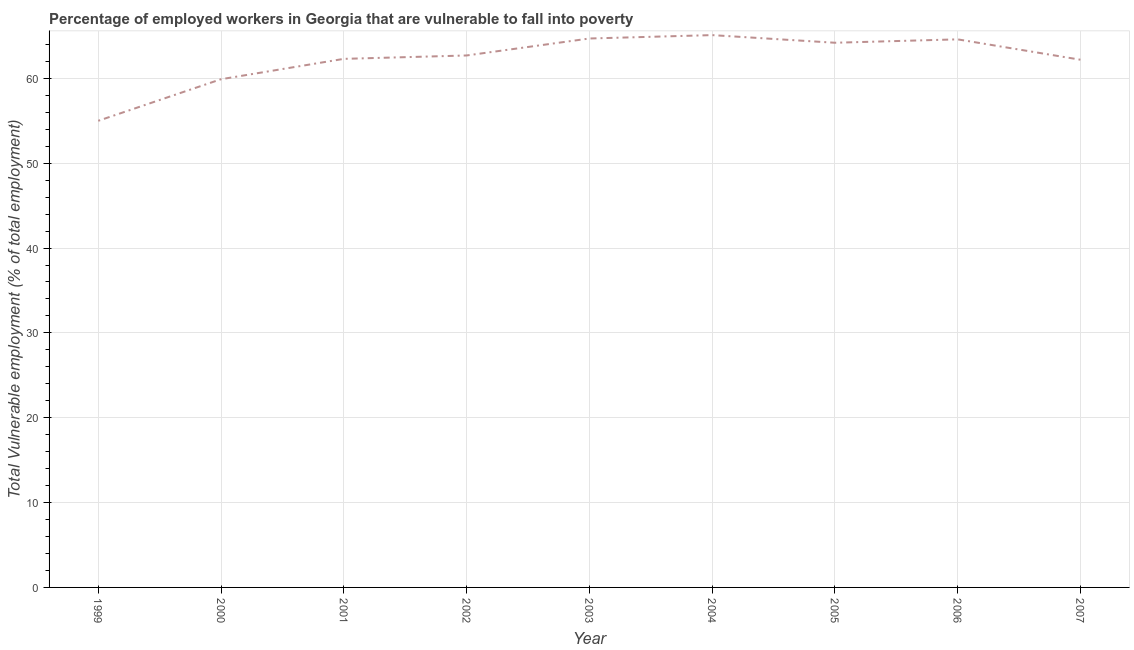What is the total vulnerable employment in 2005?
Make the answer very short. 64.2. Across all years, what is the maximum total vulnerable employment?
Your answer should be very brief. 65.1. Across all years, what is the minimum total vulnerable employment?
Offer a very short reply. 55. In which year was the total vulnerable employment maximum?
Your response must be concise. 2004. In which year was the total vulnerable employment minimum?
Make the answer very short. 1999. What is the sum of the total vulnerable employment?
Make the answer very short. 560.7. What is the difference between the total vulnerable employment in 2005 and 2007?
Give a very brief answer. 2. What is the average total vulnerable employment per year?
Give a very brief answer. 62.3. What is the median total vulnerable employment?
Provide a succinct answer. 62.7. In how many years, is the total vulnerable employment greater than 50 %?
Offer a very short reply. 9. Do a majority of the years between 2000 and 2002 (inclusive) have total vulnerable employment greater than 48 %?
Offer a very short reply. Yes. What is the ratio of the total vulnerable employment in 2004 to that in 2005?
Your answer should be very brief. 1.01. Is the difference between the total vulnerable employment in 2001 and 2007 greater than the difference between any two years?
Provide a short and direct response. No. What is the difference between the highest and the second highest total vulnerable employment?
Provide a succinct answer. 0.4. What is the difference between the highest and the lowest total vulnerable employment?
Ensure brevity in your answer.  10.1. In how many years, is the total vulnerable employment greater than the average total vulnerable employment taken over all years?
Your answer should be compact. 5. Does the total vulnerable employment monotonically increase over the years?
Your response must be concise. No. How many lines are there?
Provide a short and direct response. 1. Does the graph contain any zero values?
Your answer should be very brief. No. Does the graph contain grids?
Ensure brevity in your answer.  Yes. What is the title of the graph?
Make the answer very short. Percentage of employed workers in Georgia that are vulnerable to fall into poverty. What is the label or title of the X-axis?
Keep it short and to the point. Year. What is the label or title of the Y-axis?
Provide a succinct answer. Total Vulnerable employment (% of total employment). What is the Total Vulnerable employment (% of total employment) of 1999?
Your response must be concise. 55. What is the Total Vulnerable employment (% of total employment) in 2000?
Your answer should be very brief. 59.9. What is the Total Vulnerable employment (% of total employment) in 2001?
Your answer should be very brief. 62.3. What is the Total Vulnerable employment (% of total employment) in 2002?
Your answer should be very brief. 62.7. What is the Total Vulnerable employment (% of total employment) of 2003?
Give a very brief answer. 64.7. What is the Total Vulnerable employment (% of total employment) of 2004?
Your answer should be compact. 65.1. What is the Total Vulnerable employment (% of total employment) in 2005?
Your answer should be very brief. 64.2. What is the Total Vulnerable employment (% of total employment) of 2006?
Make the answer very short. 64.6. What is the Total Vulnerable employment (% of total employment) in 2007?
Your response must be concise. 62.2. What is the difference between the Total Vulnerable employment (% of total employment) in 1999 and 2001?
Provide a short and direct response. -7.3. What is the difference between the Total Vulnerable employment (% of total employment) in 1999 and 2003?
Provide a short and direct response. -9.7. What is the difference between the Total Vulnerable employment (% of total employment) in 1999 and 2005?
Offer a terse response. -9.2. What is the difference between the Total Vulnerable employment (% of total employment) in 1999 and 2006?
Provide a succinct answer. -9.6. What is the difference between the Total Vulnerable employment (% of total employment) in 1999 and 2007?
Provide a succinct answer. -7.2. What is the difference between the Total Vulnerable employment (% of total employment) in 2000 and 2003?
Ensure brevity in your answer.  -4.8. What is the difference between the Total Vulnerable employment (% of total employment) in 2000 and 2006?
Provide a short and direct response. -4.7. What is the difference between the Total Vulnerable employment (% of total employment) in 2001 and 2002?
Provide a short and direct response. -0.4. What is the difference between the Total Vulnerable employment (% of total employment) in 2001 and 2003?
Provide a succinct answer. -2.4. What is the difference between the Total Vulnerable employment (% of total employment) in 2001 and 2005?
Make the answer very short. -1.9. What is the difference between the Total Vulnerable employment (% of total employment) in 2001 and 2006?
Provide a succinct answer. -2.3. What is the difference between the Total Vulnerable employment (% of total employment) in 2002 and 2005?
Your response must be concise. -1.5. What is the difference between the Total Vulnerable employment (% of total employment) in 2002 and 2006?
Provide a succinct answer. -1.9. What is the difference between the Total Vulnerable employment (% of total employment) in 2003 and 2007?
Make the answer very short. 2.5. What is the difference between the Total Vulnerable employment (% of total employment) in 2004 and 2005?
Your answer should be compact. 0.9. What is the difference between the Total Vulnerable employment (% of total employment) in 2004 and 2006?
Make the answer very short. 0.5. What is the difference between the Total Vulnerable employment (% of total employment) in 2004 and 2007?
Ensure brevity in your answer.  2.9. What is the difference between the Total Vulnerable employment (% of total employment) in 2005 and 2006?
Provide a succinct answer. -0.4. What is the difference between the Total Vulnerable employment (% of total employment) in 2005 and 2007?
Keep it short and to the point. 2. What is the difference between the Total Vulnerable employment (% of total employment) in 2006 and 2007?
Offer a very short reply. 2.4. What is the ratio of the Total Vulnerable employment (% of total employment) in 1999 to that in 2000?
Ensure brevity in your answer.  0.92. What is the ratio of the Total Vulnerable employment (% of total employment) in 1999 to that in 2001?
Provide a succinct answer. 0.88. What is the ratio of the Total Vulnerable employment (% of total employment) in 1999 to that in 2002?
Give a very brief answer. 0.88. What is the ratio of the Total Vulnerable employment (% of total employment) in 1999 to that in 2003?
Your answer should be compact. 0.85. What is the ratio of the Total Vulnerable employment (% of total employment) in 1999 to that in 2004?
Make the answer very short. 0.84. What is the ratio of the Total Vulnerable employment (% of total employment) in 1999 to that in 2005?
Provide a short and direct response. 0.86. What is the ratio of the Total Vulnerable employment (% of total employment) in 1999 to that in 2006?
Your answer should be very brief. 0.85. What is the ratio of the Total Vulnerable employment (% of total employment) in 1999 to that in 2007?
Offer a terse response. 0.88. What is the ratio of the Total Vulnerable employment (% of total employment) in 2000 to that in 2002?
Keep it short and to the point. 0.95. What is the ratio of the Total Vulnerable employment (% of total employment) in 2000 to that in 2003?
Your response must be concise. 0.93. What is the ratio of the Total Vulnerable employment (% of total employment) in 2000 to that in 2005?
Offer a very short reply. 0.93. What is the ratio of the Total Vulnerable employment (% of total employment) in 2000 to that in 2006?
Your answer should be very brief. 0.93. What is the ratio of the Total Vulnerable employment (% of total employment) in 2001 to that in 2003?
Your response must be concise. 0.96. What is the ratio of the Total Vulnerable employment (% of total employment) in 2001 to that in 2004?
Offer a very short reply. 0.96. What is the ratio of the Total Vulnerable employment (% of total employment) in 2001 to that in 2007?
Provide a succinct answer. 1. What is the ratio of the Total Vulnerable employment (% of total employment) in 2002 to that in 2003?
Give a very brief answer. 0.97. What is the ratio of the Total Vulnerable employment (% of total employment) in 2002 to that in 2004?
Your answer should be compact. 0.96. What is the ratio of the Total Vulnerable employment (% of total employment) in 2002 to that in 2005?
Provide a short and direct response. 0.98. What is the ratio of the Total Vulnerable employment (% of total employment) in 2002 to that in 2007?
Provide a short and direct response. 1.01. What is the ratio of the Total Vulnerable employment (% of total employment) in 2003 to that in 2004?
Your answer should be very brief. 0.99. What is the ratio of the Total Vulnerable employment (% of total employment) in 2003 to that in 2006?
Give a very brief answer. 1. What is the ratio of the Total Vulnerable employment (% of total employment) in 2004 to that in 2005?
Your answer should be compact. 1.01. What is the ratio of the Total Vulnerable employment (% of total employment) in 2004 to that in 2007?
Provide a succinct answer. 1.05. What is the ratio of the Total Vulnerable employment (% of total employment) in 2005 to that in 2007?
Give a very brief answer. 1.03. What is the ratio of the Total Vulnerable employment (% of total employment) in 2006 to that in 2007?
Your answer should be very brief. 1.04. 